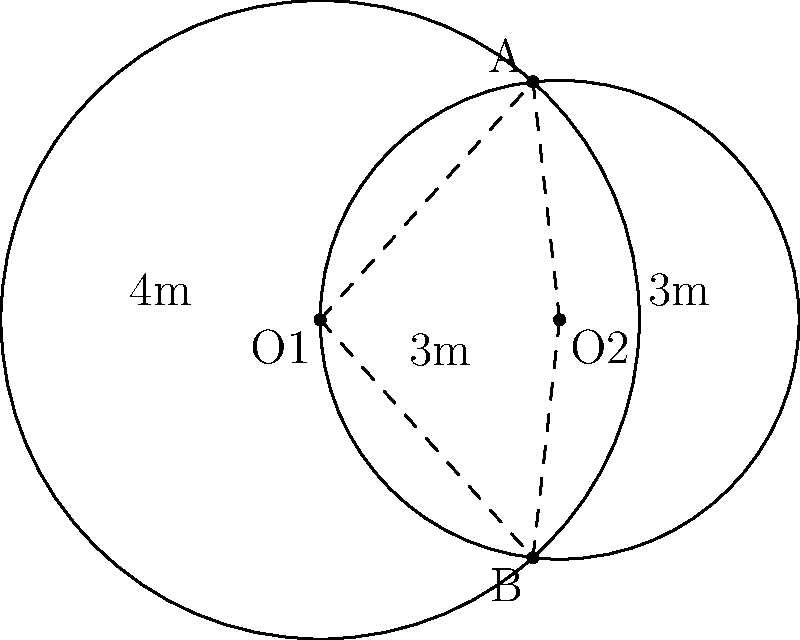At a Cranberries tribute concert, two circular stage platforms are set up side by side. The larger platform has a radius of 4 meters, while the smaller one has a radius of 3 meters. The centers of the platforms are 3 meters apart. What is the width of the overlapping area between the two platforms, measured along the line connecting their centers? Let's solve this step-by-step:

1) We can treat this as a problem of two intersecting circles. Let's call the center of the larger circle O1 and the center of the smaller circle O2.

2) We know:
   - Radius of circle O1 (r1) = 4 meters
   - Radius of circle O2 (r2) = 3 meters
   - Distance between centers (d) = 3 meters

3) To find the width of the overlapping area, we need to calculate the distance between the two intersection points along the line connecting the centers.

4) We can use the formula for the distance between intersection points of two circles:

   $$2\sqrt{\frac{(r1+r2+d)(r1-r2+d)(r1+r2-d)(-r1+r2+d)}{4d^2}}$$

5) Let's substitute our values:

   $$2\sqrt{\frac{(4+3+3)(4-3+3)(4+3-3)(-4+3+3)}{4(3^2)}}$$

6) Simplify:

   $$2\sqrt{\frac{10 \cdot 4 \cdot 4 \cdot 2}{36}} = 2\sqrt{\frac{320}{36}} = 2\sqrt{\frac{160}{18}}$$

7) Simplify further:

   $$2\sqrt{\frac{80}{9}} = \frac{2\sqrt{80}}{\sqrt{9}} = \frac{2\sqrt{80}}{3}$$

8) Simplify $\sqrt{80}$:

   $$\frac{2\sqrt{16 \cdot 5}}{3} = \frac{2 \cdot 4\sqrt{5}}{3} = \frac{8\sqrt{5}}{3}$$

Therefore, the width of the overlapping area is $\frac{8\sqrt{5}}{3}$ meters.
Answer: $\frac{8\sqrt{5}}{3}$ meters 